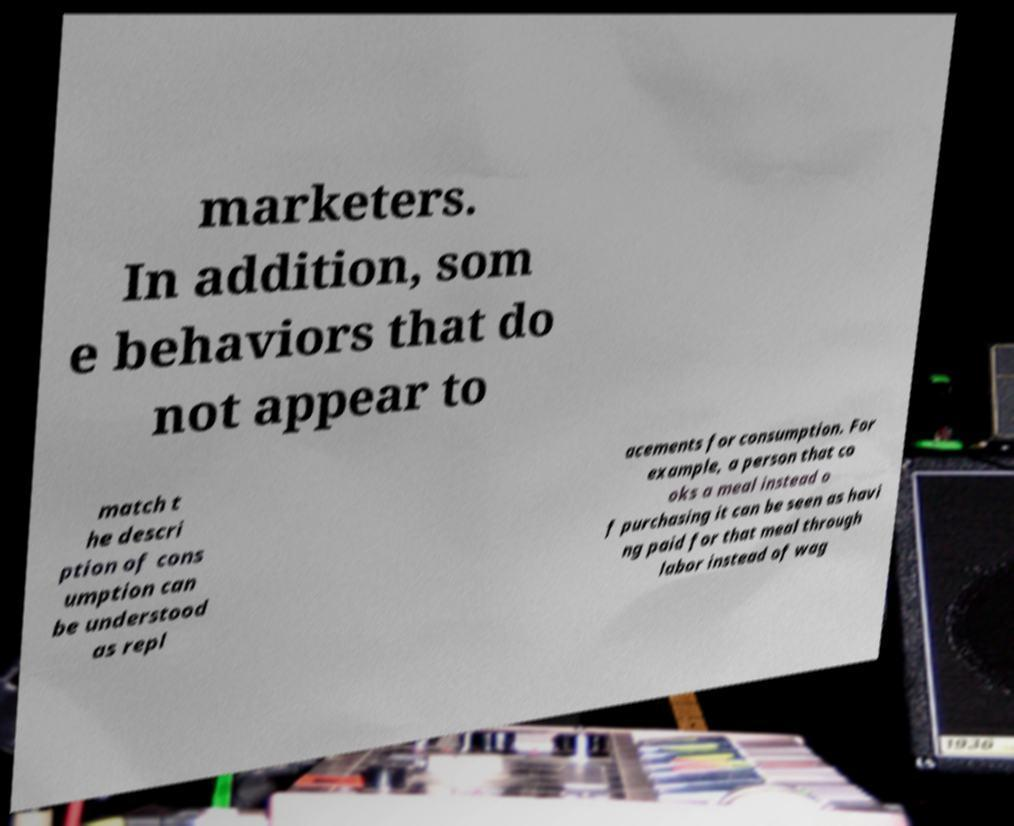Can you read and provide the text displayed in the image?This photo seems to have some interesting text. Can you extract and type it out for me? marketers. In addition, som e behaviors that do not appear to match t he descri ption of cons umption can be understood as repl acements for consumption. For example, a person that co oks a meal instead o f purchasing it can be seen as havi ng paid for that meal through labor instead of wag 